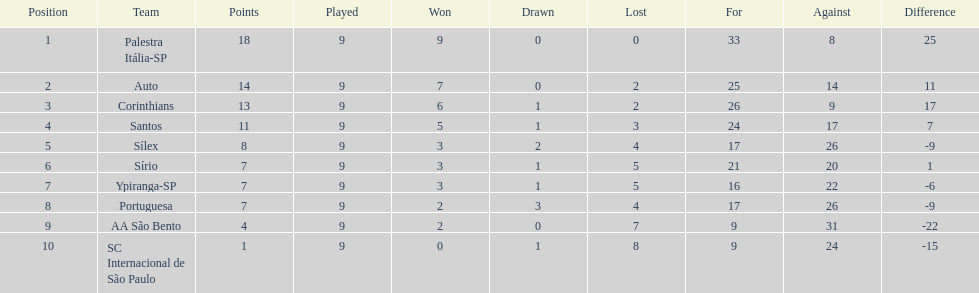How many points were automatically given to the brazilian football team in the year 1926? 14. 